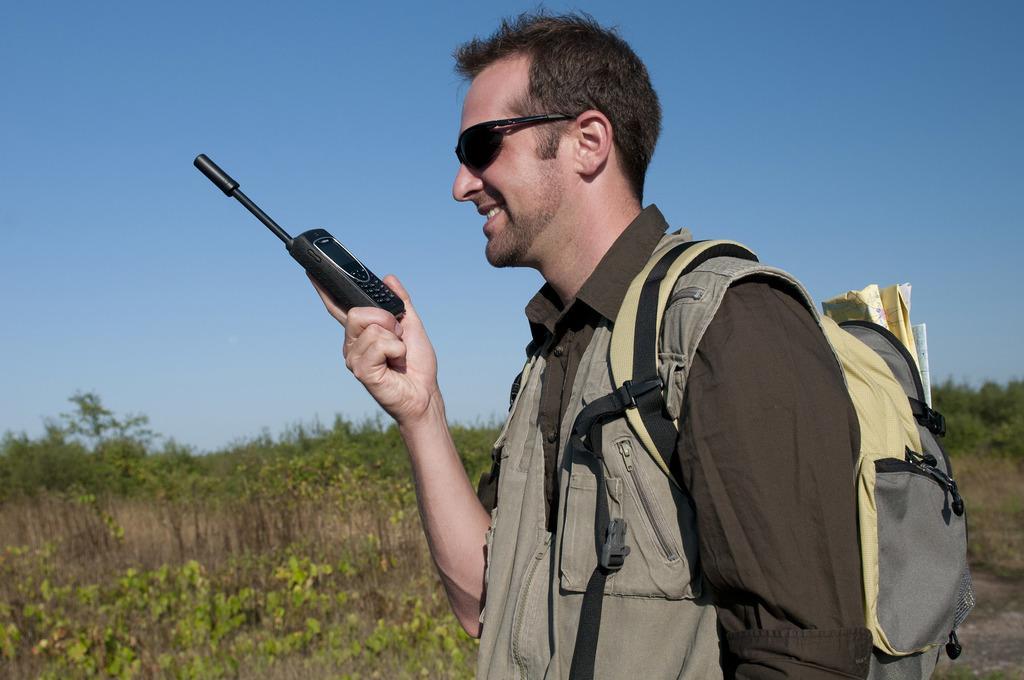Could you give a brief overview of what you see in this image? In this image, I can see the man standing and smiling. He is holding a walkie talkie in his hand. In the background, there are trees and the sky. 